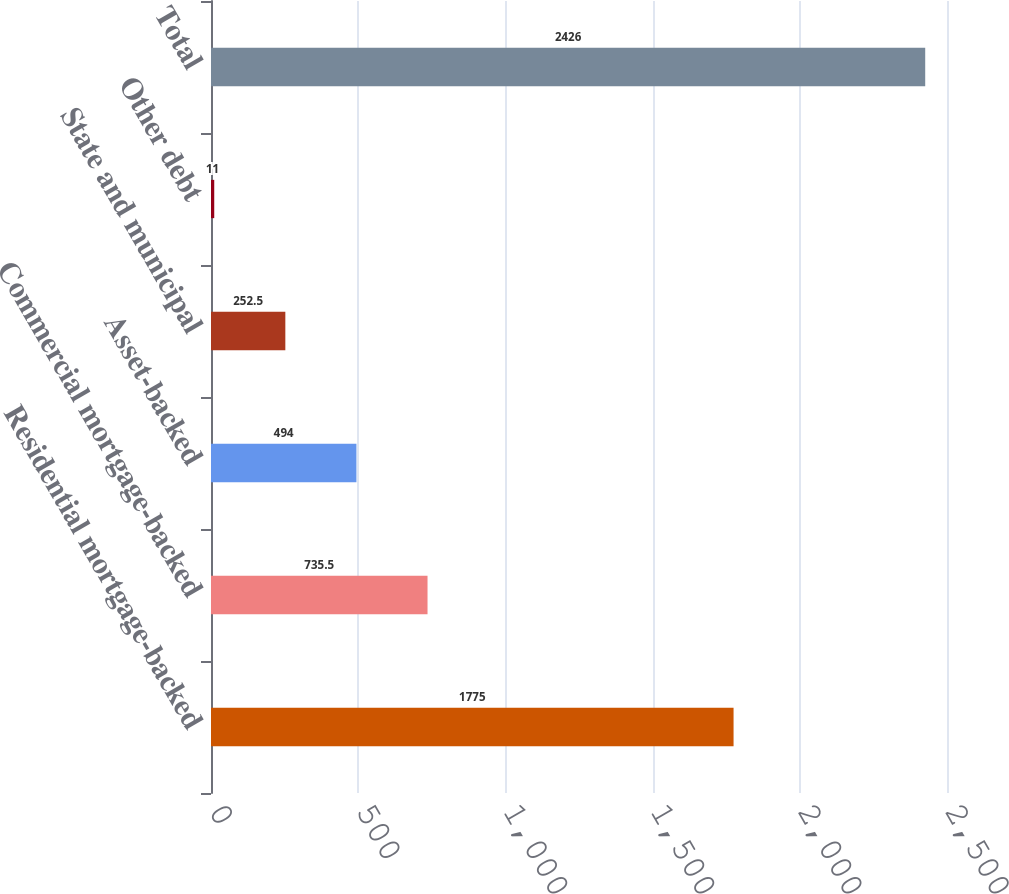<chart> <loc_0><loc_0><loc_500><loc_500><bar_chart><fcel>Residential mortgage-backed<fcel>Commercial mortgage-backed<fcel>Asset-backed<fcel>State and municipal<fcel>Other debt<fcel>Total<nl><fcel>1775<fcel>735.5<fcel>494<fcel>252.5<fcel>11<fcel>2426<nl></chart> 